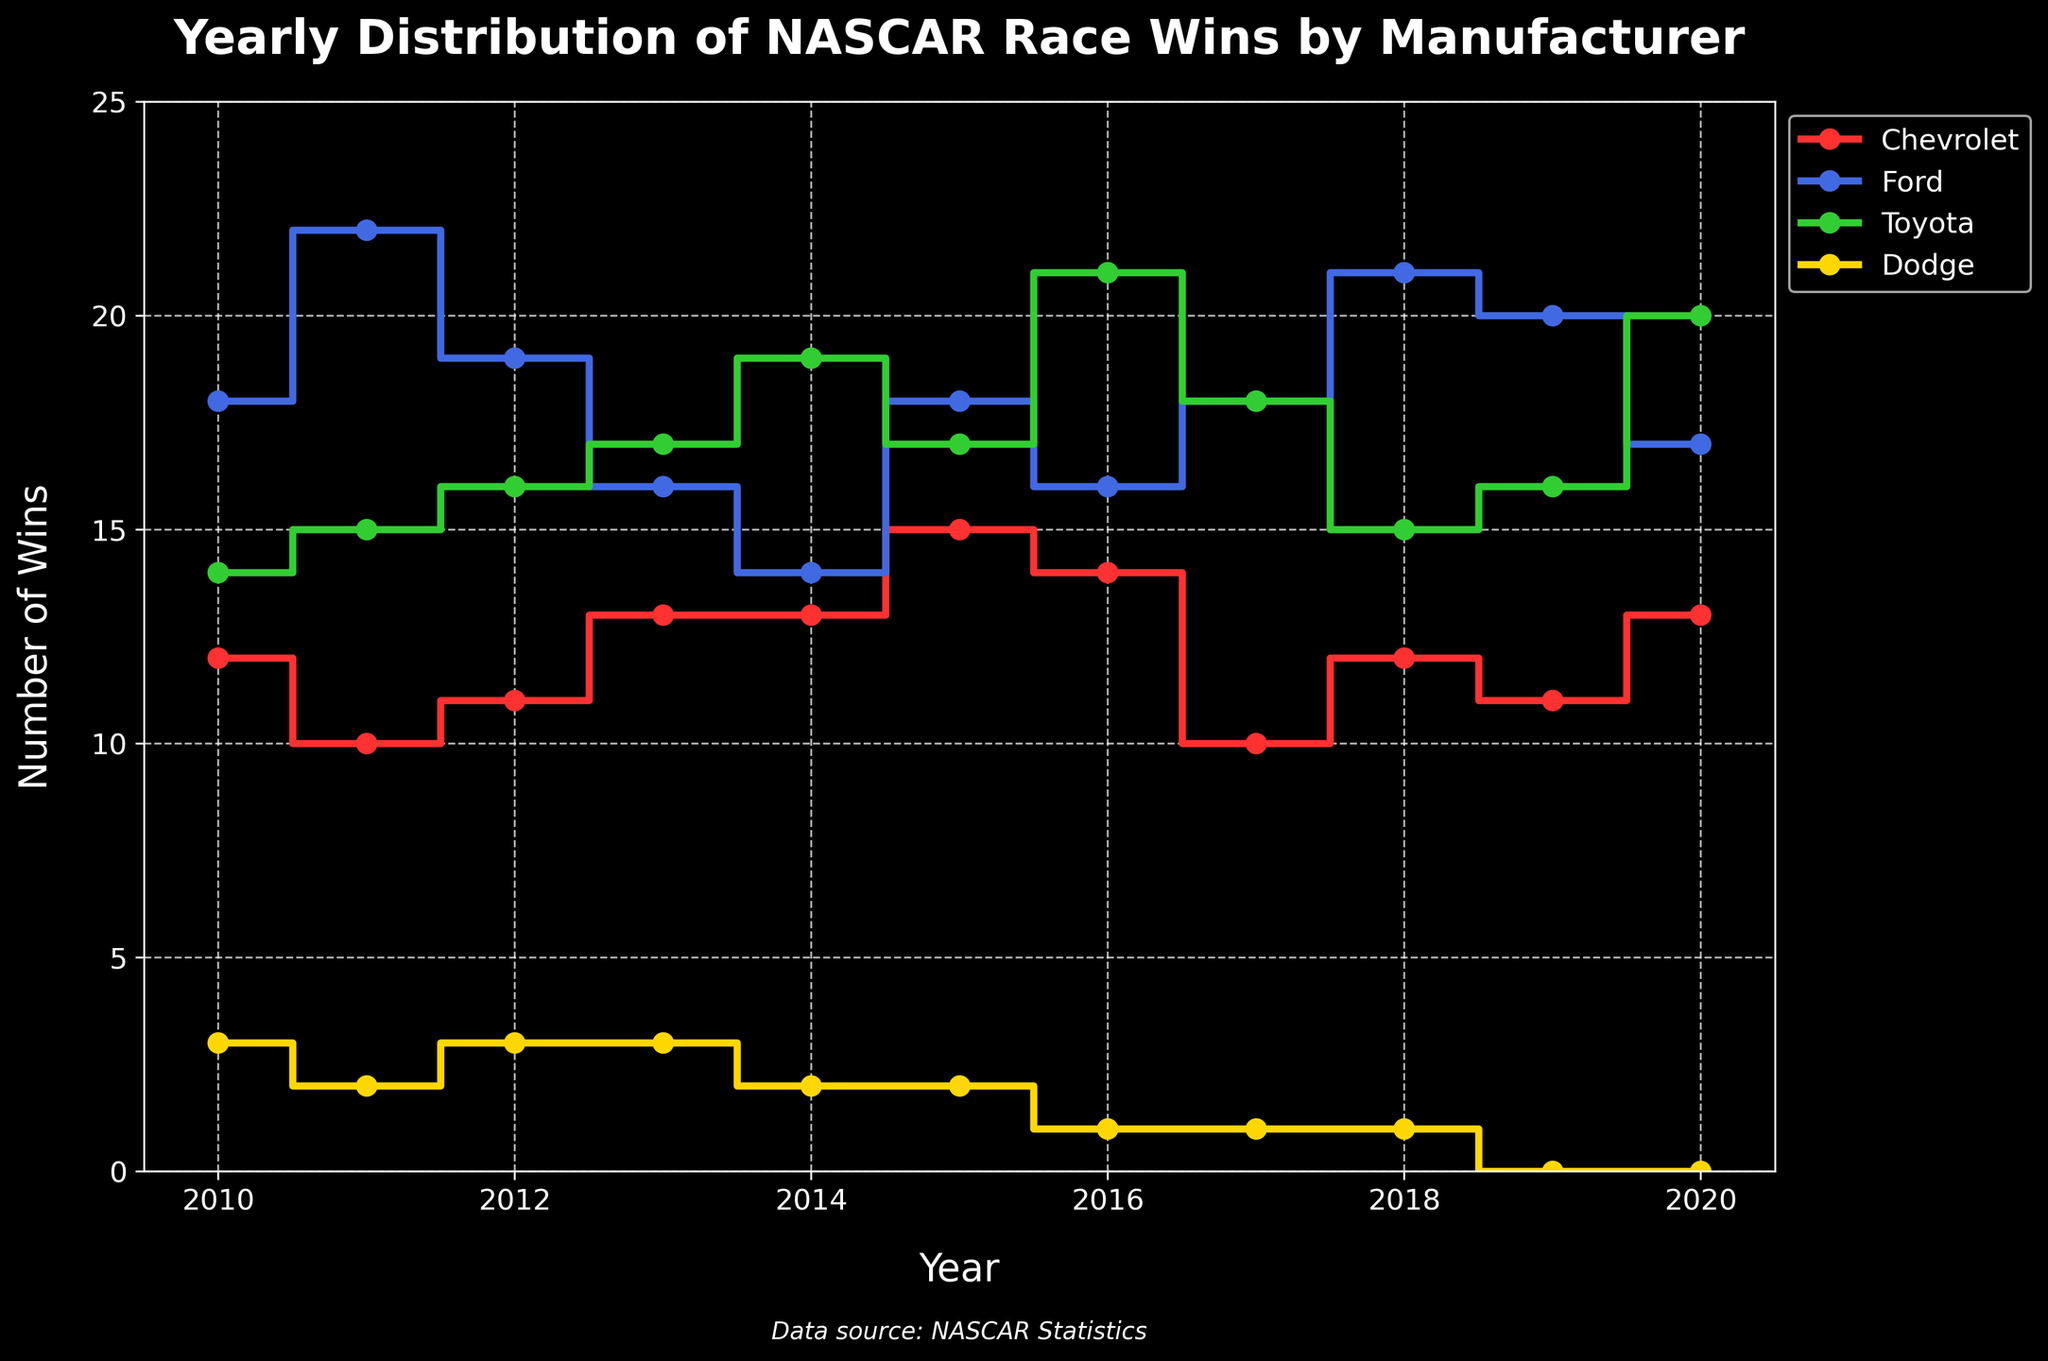What is the title of the plot? The title of the plot is displayed at the top center of the figure. It reads "Yearly Distribution of NASCAR Race Wins by Manufacturer".
Answer: Yearly Distribution of NASCAR Race Wins by Manufacturer Which manufacturer had the most race wins in 2010? By looking at the position of the data points for 2010 on the plot, we can see that Ford has the highest number of wins, as it is the highest on the y-axis for that year.
Answer: Ford How many wins did Dodge have in 2019? Locate the data point for Dodge in 2019. The stair plot for Dodge shows a position at 0 on the y-axis in 2019.
Answer: 0 Which manufacturer shows an increasing trend in wins from 2010 to 2020? Examining the plots for all manufacturers, Toyota shows a clear increasing trend from 14 wins in 2010 to 20 wins in 2020.
Answer: Toyota What year did Chevrolet have the most wins, and how many wins were there? By observing the Chevrolet plot, we notice that the most wins are in 2015 with a total of 15 wins, which is the highest point for the Chevrolet data line.
Answer: 2015, 15 How does the number of wins for Toyota in 2014 compare to its wins in 2010? Check the data points for Toyota in 2014 and 2010. Toyota had 19 wins in 2014 and 14 wins in 2010. Therefore, 2014 had more wins.
Answer: 2014 had more wins Which manufacturer had the least wins overall from 2010 to 2020? By seeing the height of the lines from 2010 to 2020, Dodge consistently has the fewest wins, staying close to 0 and at most reaching 3 wins per year.
Answer: Dodge What is the combined total number of wins for Ford and Toyota in 2018? From the plot, Ford had 21 wins and Toyota had 15 wins in 2018. Adding these together: 21 + 15 = 36.
Answer: 36 Did any manufacturer achieve exactly 20 wins in any year within the range? If so, which manufacturer and in what year? Look at the data lines to find if any hit the 20 wins mark on the y-axis. Toyota had exactly 20 wins in 2020 while Ford had 20 wins in 2019.
Answer: Toyota in 2020, Ford in 2019 Did any manufacturer show a marked decrease in wins in a specific year? If so, provide details. Observing the trends, Chevrolet's wins decreased from 14 in 2016 to 10 in 2017, showing a marked decrease.
Answer: Chevrolet's wins decreased from 14 in 2016 to 10 in 2017 